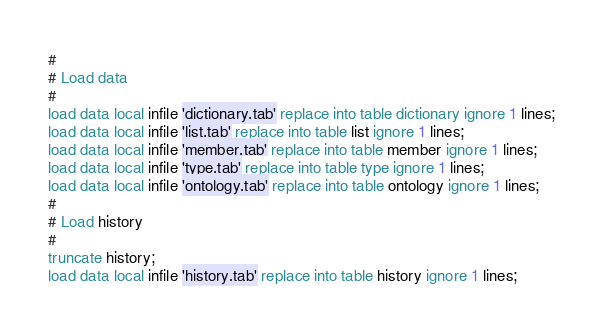<code> <loc_0><loc_0><loc_500><loc_500><_SQL_>#
# Load data
#
load data local infile 'dictionary.tab' replace into table dictionary ignore 1 lines;
load data local infile 'list.tab' replace into table list ignore 1 lines;
load data local infile 'member.tab' replace into table member ignore 1 lines;
load data local infile 'type.tab' replace into table type ignore 1 lines;
load data local infile 'ontology.tab' replace into table ontology ignore 1 lines;
#
# Load history
#
truncate history;
load data local infile 'history.tab' replace into table history ignore 1 lines;
</code> 